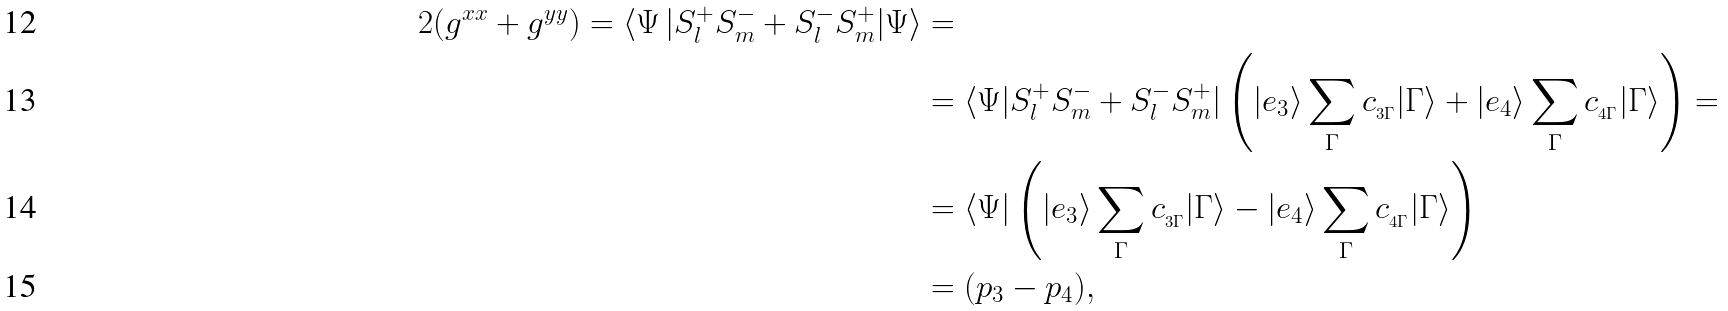<formula> <loc_0><loc_0><loc_500><loc_500>2 ( g ^ { x x } + g ^ { y y } ) = \langle \Psi \, | S ^ { + } _ { l } S ^ { - } _ { m } + S ^ { - } _ { l } S ^ { + } _ { m } | \Psi \rangle & = \\ & = \langle \Psi | S ^ { + } _ { l } S ^ { - } _ { m } + S ^ { - } _ { l } S ^ { + } _ { m } | \left ( | e _ { 3 } \rangle \sum _ { \Gamma } c _ { _ { 3 \Gamma } } | \Gamma \rangle + | e _ { 4 } \rangle \sum _ { \Gamma } c _ { _ { 4 \Gamma } } | \Gamma \rangle \right ) = \\ & = \langle \Psi | \left ( | e _ { 3 } \rangle \sum _ { \Gamma } c _ { _ { 3 \Gamma } } | \Gamma \rangle - | e _ { 4 } \rangle \sum _ { \Gamma } c _ { _ { 4 \Gamma } } | \Gamma \rangle \right ) \\ & = ( p _ { 3 } - p _ { 4 } ) ,</formula> 